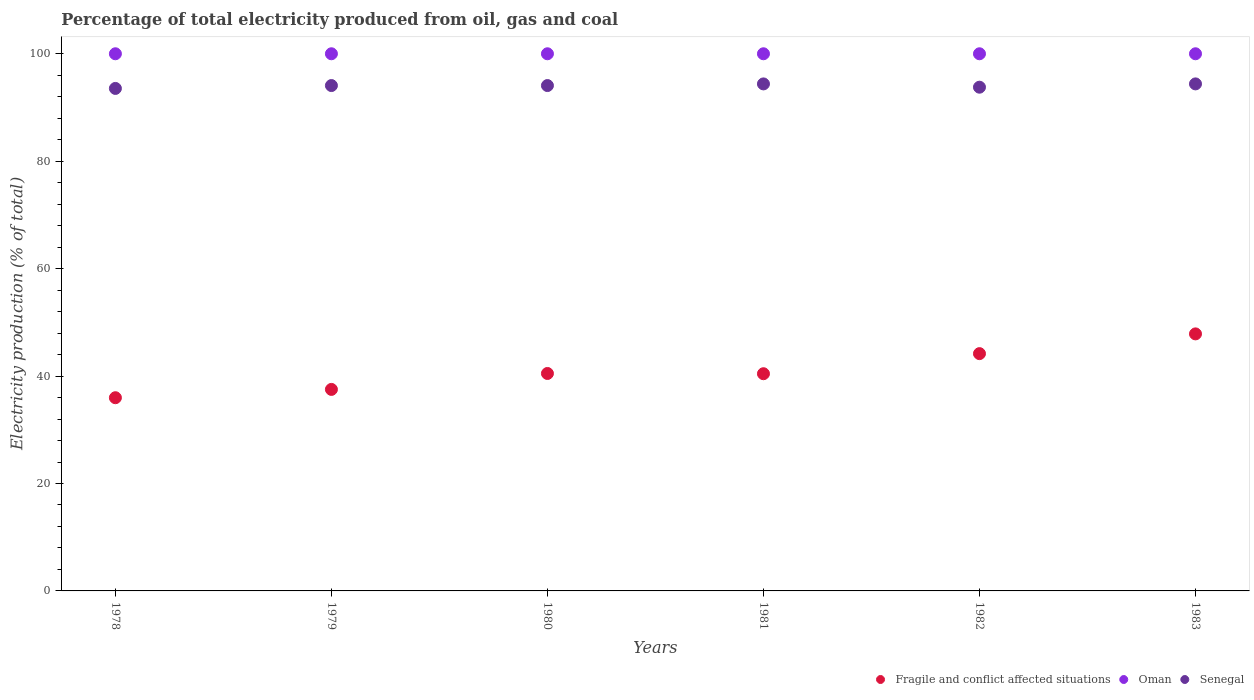How many different coloured dotlines are there?
Ensure brevity in your answer.  3. Is the number of dotlines equal to the number of legend labels?
Your response must be concise. Yes. What is the electricity production in in Fragile and conflict affected situations in 1979?
Your answer should be very brief. 37.52. Across all years, what is the maximum electricity production in in Senegal?
Your response must be concise. 94.39. In which year was the electricity production in in Senegal maximum?
Your answer should be compact. 1983. In which year was the electricity production in in Fragile and conflict affected situations minimum?
Your answer should be very brief. 1978. What is the total electricity production in in Oman in the graph?
Make the answer very short. 600. What is the difference between the electricity production in in Fragile and conflict affected situations in 1978 and that in 1979?
Keep it short and to the point. -1.55. What is the difference between the electricity production in in Senegal in 1979 and the electricity production in in Oman in 1983?
Your answer should be very brief. -5.92. What is the average electricity production in in Oman per year?
Make the answer very short. 100. In the year 1982, what is the difference between the electricity production in in Fragile and conflict affected situations and electricity production in in Oman?
Give a very brief answer. -55.82. In how many years, is the electricity production in in Senegal greater than 84 %?
Give a very brief answer. 6. What is the ratio of the electricity production in in Senegal in 1978 to that in 1982?
Give a very brief answer. 1. What is the difference between the highest and the second highest electricity production in in Fragile and conflict affected situations?
Offer a very short reply. 3.67. In how many years, is the electricity production in in Senegal greater than the average electricity production in in Senegal taken over all years?
Offer a terse response. 4. Is the sum of the electricity production in in Senegal in 1978 and 1983 greater than the maximum electricity production in in Oman across all years?
Make the answer very short. Yes. Does the electricity production in in Senegal monotonically increase over the years?
Offer a terse response. No. What is the difference between two consecutive major ticks on the Y-axis?
Keep it short and to the point. 20. Are the values on the major ticks of Y-axis written in scientific E-notation?
Offer a terse response. No. Does the graph contain grids?
Keep it short and to the point. No. Where does the legend appear in the graph?
Give a very brief answer. Bottom right. How many legend labels are there?
Offer a terse response. 3. How are the legend labels stacked?
Provide a succinct answer. Horizontal. What is the title of the graph?
Your answer should be very brief. Percentage of total electricity produced from oil, gas and coal. Does "Nepal" appear as one of the legend labels in the graph?
Your answer should be very brief. No. What is the label or title of the X-axis?
Ensure brevity in your answer.  Years. What is the label or title of the Y-axis?
Offer a very short reply. Electricity production (% of total). What is the Electricity production (% of total) of Fragile and conflict affected situations in 1978?
Your response must be concise. 35.97. What is the Electricity production (% of total) of Senegal in 1978?
Ensure brevity in your answer.  93.55. What is the Electricity production (% of total) of Fragile and conflict affected situations in 1979?
Provide a short and direct response. 37.52. What is the Electricity production (% of total) in Senegal in 1979?
Provide a succinct answer. 94.08. What is the Electricity production (% of total) in Fragile and conflict affected situations in 1980?
Make the answer very short. 40.48. What is the Electricity production (% of total) of Senegal in 1980?
Make the answer very short. 94.08. What is the Electricity production (% of total) of Fragile and conflict affected situations in 1981?
Offer a very short reply. 40.43. What is the Electricity production (% of total) in Oman in 1981?
Offer a very short reply. 100. What is the Electricity production (% of total) of Senegal in 1981?
Your answer should be compact. 94.39. What is the Electricity production (% of total) in Fragile and conflict affected situations in 1982?
Keep it short and to the point. 44.18. What is the Electricity production (% of total) of Senegal in 1982?
Offer a terse response. 93.78. What is the Electricity production (% of total) in Fragile and conflict affected situations in 1983?
Offer a very short reply. 47.85. What is the Electricity production (% of total) in Oman in 1983?
Your response must be concise. 100. What is the Electricity production (% of total) of Senegal in 1983?
Provide a succinct answer. 94.39. Across all years, what is the maximum Electricity production (% of total) of Fragile and conflict affected situations?
Your answer should be very brief. 47.85. Across all years, what is the maximum Electricity production (% of total) in Senegal?
Keep it short and to the point. 94.39. Across all years, what is the minimum Electricity production (% of total) of Fragile and conflict affected situations?
Offer a terse response. 35.97. Across all years, what is the minimum Electricity production (% of total) of Senegal?
Provide a short and direct response. 93.55. What is the total Electricity production (% of total) in Fragile and conflict affected situations in the graph?
Offer a terse response. 246.43. What is the total Electricity production (% of total) in Oman in the graph?
Offer a very short reply. 600. What is the total Electricity production (% of total) of Senegal in the graph?
Provide a short and direct response. 564.27. What is the difference between the Electricity production (% of total) of Fragile and conflict affected situations in 1978 and that in 1979?
Offer a very short reply. -1.55. What is the difference between the Electricity production (% of total) of Oman in 1978 and that in 1979?
Offer a terse response. 0. What is the difference between the Electricity production (% of total) of Senegal in 1978 and that in 1979?
Keep it short and to the point. -0.53. What is the difference between the Electricity production (% of total) in Fragile and conflict affected situations in 1978 and that in 1980?
Make the answer very short. -4.51. What is the difference between the Electricity production (% of total) of Senegal in 1978 and that in 1980?
Your answer should be very brief. -0.53. What is the difference between the Electricity production (% of total) of Fragile and conflict affected situations in 1978 and that in 1981?
Offer a terse response. -4.47. What is the difference between the Electricity production (% of total) in Oman in 1978 and that in 1981?
Your response must be concise. 0. What is the difference between the Electricity production (% of total) in Senegal in 1978 and that in 1981?
Provide a succinct answer. -0.84. What is the difference between the Electricity production (% of total) of Fragile and conflict affected situations in 1978 and that in 1982?
Provide a short and direct response. -8.21. What is the difference between the Electricity production (% of total) of Senegal in 1978 and that in 1982?
Your answer should be compact. -0.23. What is the difference between the Electricity production (% of total) of Fragile and conflict affected situations in 1978 and that in 1983?
Give a very brief answer. -11.88. What is the difference between the Electricity production (% of total) in Senegal in 1978 and that in 1983?
Give a very brief answer. -0.84. What is the difference between the Electricity production (% of total) in Fragile and conflict affected situations in 1979 and that in 1980?
Your response must be concise. -2.97. What is the difference between the Electricity production (% of total) of Senegal in 1979 and that in 1980?
Provide a short and direct response. 0. What is the difference between the Electricity production (% of total) in Fragile and conflict affected situations in 1979 and that in 1981?
Make the answer very short. -2.92. What is the difference between the Electricity production (% of total) of Senegal in 1979 and that in 1981?
Your response must be concise. -0.31. What is the difference between the Electricity production (% of total) in Fragile and conflict affected situations in 1979 and that in 1982?
Provide a succinct answer. -6.66. What is the difference between the Electricity production (% of total) of Oman in 1979 and that in 1982?
Offer a very short reply. 0. What is the difference between the Electricity production (% of total) in Senegal in 1979 and that in 1982?
Provide a short and direct response. 0.31. What is the difference between the Electricity production (% of total) of Fragile and conflict affected situations in 1979 and that in 1983?
Offer a terse response. -10.34. What is the difference between the Electricity production (% of total) of Senegal in 1979 and that in 1983?
Offer a very short reply. -0.31. What is the difference between the Electricity production (% of total) in Fragile and conflict affected situations in 1980 and that in 1981?
Offer a terse response. 0.05. What is the difference between the Electricity production (% of total) in Senegal in 1980 and that in 1981?
Your response must be concise. -0.31. What is the difference between the Electricity production (% of total) in Fragile and conflict affected situations in 1980 and that in 1982?
Your answer should be compact. -3.7. What is the difference between the Electricity production (% of total) of Senegal in 1980 and that in 1982?
Provide a short and direct response. 0.31. What is the difference between the Electricity production (% of total) of Fragile and conflict affected situations in 1980 and that in 1983?
Your response must be concise. -7.37. What is the difference between the Electricity production (% of total) of Oman in 1980 and that in 1983?
Offer a terse response. 0. What is the difference between the Electricity production (% of total) of Senegal in 1980 and that in 1983?
Give a very brief answer. -0.31. What is the difference between the Electricity production (% of total) in Fragile and conflict affected situations in 1981 and that in 1982?
Provide a short and direct response. -3.74. What is the difference between the Electricity production (% of total) of Oman in 1981 and that in 1982?
Give a very brief answer. 0. What is the difference between the Electricity production (% of total) of Senegal in 1981 and that in 1982?
Keep it short and to the point. 0.61. What is the difference between the Electricity production (% of total) in Fragile and conflict affected situations in 1981 and that in 1983?
Offer a very short reply. -7.42. What is the difference between the Electricity production (% of total) in Senegal in 1981 and that in 1983?
Give a very brief answer. -0. What is the difference between the Electricity production (% of total) of Fragile and conflict affected situations in 1982 and that in 1983?
Make the answer very short. -3.67. What is the difference between the Electricity production (% of total) in Oman in 1982 and that in 1983?
Ensure brevity in your answer.  0. What is the difference between the Electricity production (% of total) of Senegal in 1982 and that in 1983?
Your answer should be very brief. -0.61. What is the difference between the Electricity production (% of total) in Fragile and conflict affected situations in 1978 and the Electricity production (% of total) in Oman in 1979?
Your response must be concise. -64.03. What is the difference between the Electricity production (% of total) in Fragile and conflict affected situations in 1978 and the Electricity production (% of total) in Senegal in 1979?
Ensure brevity in your answer.  -58.12. What is the difference between the Electricity production (% of total) in Oman in 1978 and the Electricity production (% of total) in Senegal in 1979?
Provide a short and direct response. 5.92. What is the difference between the Electricity production (% of total) in Fragile and conflict affected situations in 1978 and the Electricity production (% of total) in Oman in 1980?
Your response must be concise. -64.03. What is the difference between the Electricity production (% of total) of Fragile and conflict affected situations in 1978 and the Electricity production (% of total) of Senegal in 1980?
Your answer should be very brief. -58.12. What is the difference between the Electricity production (% of total) in Oman in 1978 and the Electricity production (% of total) in Senegal in 1980?
Offer a terse response. 5.92. What is the difference between the Electricity production (% of total) in Fragile and conflict affected situations in 1978 and the Electricity production (% of total) in Oman in 1981?
Offer a terse response. -64.03. What is the difference between the Electricity production (% of total) of Fragile and conflict affected situations in 1978 and the Electricity production (% of total) of Senegal in 1981?
Give a very brief answer. -58.42. What is the difference between the Electricity production (% of total) of Oman in 1978 and the Electricity production (% of total) of Senegal in 1981?
Your answer should be compact. 5.61. What is the difference between the Electricity production (% of total) in Fragile and conflict affected situations in 1978 and the Electricity production (% of total) in Oman in 1982?
Keep it short and to the point. -64.03. What is the difference between the Electricity production (% of total) in Fragile and conflict affected situations in 1978 and the Electricity production (% of total) in Senegal in 1982?
Your response must be concise. -57.81. What is the difference between the Electricity production (% of total) of Oman in 1978 and the Electricity production (% of total) of Senegal in 1982?
Give a very brief answer. 6.22. What is the difference between the Electricity production (% of total) in Fragile and conflict affected situations in 1978 and the Electricity production (% of total) in Oman in 1983?
Provide a succinct answer. -64.03. What is the difference between the Electricity production (% of total) in Fragile and conflict affected situations in 1978 and the Electricity production (% of total) in Senegal in 1983?
Your answer should be compact. -58.43. What is the difference between the Electricity production (% of total) in Oman in 1978 and the Electricity production (% of total) in Senegal in 1983?
Provide a succinct answer. 5.61. What is the difference between the Electricity production (% of total) in Fragile and conflict affected situations in 1979 and the Electricity production (% of total) in Oman in 1980?
Offer a very short reply. -62.48. What is the difference between the Electricity production (% of total) of Fragile and conflict affected situations in 1979 and the Electricity production (% of total) of Senegal in 1980?
Ensure brevity in your answer.  -56.57. What is the difference between the Electricity production (% of total) of Oman in 1979 and the Electricity production (% of total) of Senegal in 1980?
Provide a short and direct response. 5.92. What is the difference between the Electricity production (% of total) of Fragile and conflict affected situations in 1979 and the Electricity production (% of total) of Oman in 1981?
Offer a terse response. -62.48. What is the difference between the Electricity production (% of total) of Fragile and conflict affected situations in 1979 and the Electricity production (% of total) of Senegal in 1981?
Offer a very short reply. -56.87. What is the difference between the Electricity production (% of total) in Oman in 1979 and the Electricity production (% of total) in Senegal in 1981?
Offer a terse response. 5.61. What is the difference between the Electricity production (% of total) in Fragile and conflict affected situations in 1979 and the Electricity production (% of total) in Oman in 1982?
Ensure brevity in your answer.  -62.48. What is the difference between the Electricity production (% of total) in Fragile and conflict affected situations in 1979 and the Electricity production (% of total) in Senegal in 1982?
Give a very brief answer. -56.26. What is the difference between the Electricity production (% of total) of Oman in 1979 and the Electricity production (% of total) of Senegal in 1982?
Keep it short and to the point. 6.22. What is the difference between the Electricity production (% of total) of Fragile and conflict affected situations in 1979 and the Electricity production (% of total) of Oman in 1983?
Make the answer very short. -62.48. What is the difference between the Electricity production (% of total) in Fragile and conflict affected situations in 1979 and the Electricity production (% of total) in Senegal in 1983?
Your response must be concise. -56.88. What is the difference between the Electricity production (% of total) in Oman in 1979 and the Electricity production (% of total) in Senegal in 1983?
Your response must be concise. 5.61. What is the difference between the Electricity production (% of total) of Fragile and conflict affected situations in 1980 and the Electricity production (% of total) of Oman in 1981?
Make the answer very short. -59.52. What is the difference between the Electricity production (% of total) of Fragile and conflict affected situations in 1980 and the Electricity production (% of total) of Senegal in 1981?
Ensure brevity in your answer.  -53.91. What is the difference between the Electricity production (% of total) of Oman in 1980 and the Electricity production (% of total) of Senegal in 1981?
Give a very brief answer. 5.61. What is the difference between the Electricity production (% of total) of Fragile and conflict affected situations in 1980 and the Electricity production (% of total) of Oman in 1982?
Ensure brevity in your answer.  -59.52. What is the difference between the Electricity production (% of total) of Fragile and conflict affected situations in 1980 and the Electricity production (% of total) of Senegal in 1982?
Ensure brevity in your answer.  -53.3. What is the difference between the Electricity production (% of total) in Oman in 1980 and the Electricity production (% of total) in Senegal in 1982?
Provide a short and direct response. 6.22. What is the difference between the Electricity production (% of total) of Fragile and conflict affected situations in 1980 and the Electricity production (% of total) of Oman in 1983?
Ensure brevity in your answer.  -59.52. What is the difference between the Electricity production (% of total) of Fragile and conflict affected situations in 1980 and the Electricity production (% of total) of Senegal in 1983?
Keep it short and to the point. -53.91. What is the difference between the Electricity production (% of total) in Oman in 1980 and the Electricity production (% of total) in Senegal in 1983?
Provide a succinct answer. 5.61. What is the difference between the Electricity production (% of total) in Fragile and conflict affected situations in 1981 and the Electricity production (% of total) in Oman in 1982?
Keep it short and to the point. -59.57. What is the difference between the Electricity production (% of total) of Fragile and conflict affected situations in 1981 and the Electricity production (% of total) of Senegal in 1982?
Offer a very short reply. -53.34. What is the difference between the Electricity production (% of total) of Oman in 1981 and the Electricity production (% of total) of Senegal in 1982?
Ensure brevity in your answer.  6.22. What is the difference between the Electricity production (% of total) in Fragile and conflict affected situations in 1981 and the Electricity production (% of total) in Oman in 1983?
Your response must be concise. -59.57. What is the difference between the Electricity production (% of total) of Fragile and conflict affected situations in 1981 and the Electricity production (% of total) of Senegal in 1983?
Provide a succinct answer. -53.96. What is the difference between the Electricity production (% of total) in Oman in 1981 and the Electricity production (% of total) in Senegal in 1983?
Your answer should be compact. 5.61. What is the difference between the Electricity production (% of total) of Fragile and conflict affected situations in 1982 and the Electricity production (% of total) of Oman in 1983?
Provide a short and direct response. -55.82. What is the difference between the Electricity production (% of total) of Fragile and conflict affected situations in 1982 and the Electricity production (% of total) of Senegal in 1983?
Your response must be concise. -50.22. What is the difference between the Electricity production (% of total) in Oman in 1982 and the Electricity production (% of total) in Senegal in 1983?
Offer a terse response. 5.61. What is the average Electricity production (% of total) in Fragile and conflict affected situations per year?
Your answer should be very brief. 41.07. What is the average Electricity production (% of total) in Senegal per year?
Give a very brief answer. 94.05. In the year 1978, what is the difference between the Electricity production (% of total) in Fragile and conflict affected situations and Electricity production (% of total) in Oman?
Provide a succinct answer. -64.03. In the year 1978, what is the difference between the Electricity production (% of total) in Fragile and conflict affected situations and Electricity production (% of total) in Senegal?
Offer a very short reply. -57.58. In the year 1978, what is the difference between the Electricity production (% of total) in Oman and Electricity production (% of total) in Senegal?
Provide a succinct answer. 6.45. In the year 1979, what is the difference between the Electricity production (% of total) of Fragile and conflict affected situations and Electricity production (% of total) of Oman?
Give a very brief answer. -62.48. In the year 1979, what is the difference between the Electricity production (% of total) of Fragile and conflict affected situations and Electricity production (% of total) of Senegal?
Ensure brevity in your answer.  -56.57. In the year 1979, what is the difference between the Electricity production (% of total) of Oman and Electricity production (% of total) of Senegal?
Give a very brief answer. 5.92. In the year 1980, what is the difference between the Electricity production (% of total) in Fragile and conflict affected situations and Electricity production (% of total) in Oman?
Give a very brief answer. -59.52. In the year 1980, what is the difference between the Electricity production (% of total) of Fragile and conflict affected situations and Electricity production (% of total) of Senegal?
Provide a succinct answer. -53.6. In the year 1980, what is the difference between the Electricity production (% of total) in Oman and Electricity production (% of total) in Senegal?
Make the answer very short. 5.92. In the year 1981, what is the difference between the Electricity production (% of total) of Fragile and conflict affected situations and Electricity production (% of total) of Oman?
Offer a very short reply. -59.57. In the year 1981, what is the difference between the Electricity production (% of total) of Fragile and conflict affected situations and Electricity production (% of total) of Senegal?
Your response must be concise. -53.96. In the year 1981, what is the difference between the Electricity production (% of total) in Oman and Electricity production (% of total) in Senegal?
Keep it short and to the point. 5.61. In the year 1982, what is the difference between the Electricity production (% of total) in Fragile and conflict affected situations and Electricity production (% of total) in Oman?
Your answer should be very brief. -55.82. In the year 1982, what is the difference between the Electricity production (% of total) in Fragile and conflict affected situations and Electricity production (% of total) in Senegal?
Offer a terse response. -49.6. In the year 1982, what is the difference between the Electricity production (% of total) of Oman and Electricity production (% of total) of Senegal?
Your response must be concise. 6.22. In the year 1983, what is the difference between the Electricity production (% of total) in Fragile and conflict affected situations and Electricity production (% of total) in Oman?
Make the answer very short. -52.15. In the year 1983, what is the difference between the Electricity production (% of total) in Fragile and conflict affected situations and Electricity production (% of total) in Senegal?
Keep it short and to the point. -46.54. In the year 1983, what is the difference between the Electricity production (% of total) in Oman and Electricity production (% of total) in Senegal?
Your response must be concise. 5.61. What is the ratio of the Electricity production (% of total) of Fragile and conflict affected situations in 1978 to that in 1979?
Your answer should be very brief. 0.96. What is the ratio of the Electricity production (% of total) in Oman in 1978 to that in 1979?
Make the answer very short. 1. What is the ratio of the Electricity production (% of total) in Senegal in 1978 to that in 1979?
Offer a terse response. 0.99. What is the ratio of the Electricity production (% of total) of Fragile and conflict affected situations in 1978 to that in 1980?
Offer a very short reply. 0.89. What is the ratio of the Electricity production (% of total) of Fragile and conflict affected situations in 1978 to that in 1981?
Offer a very short reply. 0.89. What is the ratio of the Electricity production (% of total) of Oman in 1978 to that in 1981?
Give a very brief answer. 1. What is the ratio of the Electricity production (% of total) in Senegal in 1978 to that in 1981?
Offer a very short reply. 0.99. What is the ratio of the Electricity production (% of total) of Fragile and conflict affected situations in 1978 to that in 1982?
Provide a short and direct response. 0.81. What is the ratio of the Electricity production (% of total) in Fragile and conflict affected situations in 1978 to that in 1983?
Provide a succinct answer. 0.75. What is the ratio of the Electricity production (% of total) of Oman in 1978 to that in 1983?
Offer a terse response. 1. What is the ratio of the Electricity production (% of total) in Fragile and conflict affected situations in 1979 to that in 1980?
Provide a succinct answer. 0.93. What is the ratio of the Electricity production (% of total) of Fragile and conflict affected situations in 1979 to that in 1981?
Offer a terse response. 0.93. What is the ratio of the Electricity production (% of total) in Senegal in 1979 to that in 1981?
Offer a terse response. 1. What is the ratio of the Electricity production (% of total) of Fragile and conflict affected situations in 1979 to that in 1982?
Provide a short and direct response. 0.85. What is the ratio of the Electricity production (% of total) in Oman in 1979 to that in 1982?
Your answer should be compact. 1. What is the ratio of the Electricity production (% of total) of Fragile and conflict affected situations in 1979 to that in 1983?
Your response must be concise. 0.78. What is the ratio of the Electricity production (% of total) in Oman in 1979 to that in 1983?
Offer a very short reply. 1. What is the ratio of the Electricity production (% of total) in Senegal in 1979 to that in 1983?
Your answer should be very brief. 1. What is the ratio of the Electricity production (% of total) of Fragile and conflict affected situations in 1980 to that in 1981?
Offer a very short reply. 1. What is the ratio of the Electricity production (% of total) of Oman in 1980 to that in 1981?
Keep it short and to the point. 1. What is the ratio of the Electricity production (% of total) of Senegal in 1980 to that in 1981?
Make the answer very short. 1. What is the ratio of the Electricity production (% of total) in Fragile and conflict affected situations in 1980 to that in 1982?
Provide a succinct answer. 0.92. What is the ratio of the Electricity production (% of total) in Fragile and conflict affected situations in 1980 to that in 1983?
Offer a terse response. 0.85. What is the ratio of the Electricity production (% of total) of Oman in 1980 to that in 1983?
Ensure brevity in your answer.  1. What is the ratio of the Electricity production (% of total) in Senegal in 1980 to that in 1983?
Your answer should be very brief. 1. What is the ratio of the Electricity production (% of total) of Fragile and conflict affected situations in 1981 to that in 1982?
Keep it short and to the point. 0.92. What is the ratio of the Electricity production (% of total) of Senegal in 1981 to that in 1982?
Ensure brevity in your answer.  1.01. What is the ratio of the Electricity production (% of total) in Fragile and conflict affected situations in 1981 to that in 1983?
Your answer should be very brief. 0.84. What is the ratio of the Electricity production (% of total) of Oman in 1981 to that in 1983?
Your answer should be compact. 1. What is the ratio of the Electricity production (% of total) of Fragile and conflict affected situations in 1982 to that in 1983?
Provide a succinct answer. 0.92. What is the difference between the highest and the second highest Electricity production (% of total) of Fragile and conflict affected situations?
Give a very brief answer. 3.67. What is the difference between the highest and the second highest Electricity production (% of total) of Oman?
Offer a very short reply. 0. What is the difference between the highest and the second highest Electricity production (% of total) in Senegal?
Offer a terse response. 0. What is the difference between the highest and the lowest Electricity production (% of total) of Fragile and conflict affected situations?
Your answer should be compact. 11.88. What is the difference between the highest and the lowest Electricity production (% of total) in Senegal?
Provide a succinct answer. 0.84. 